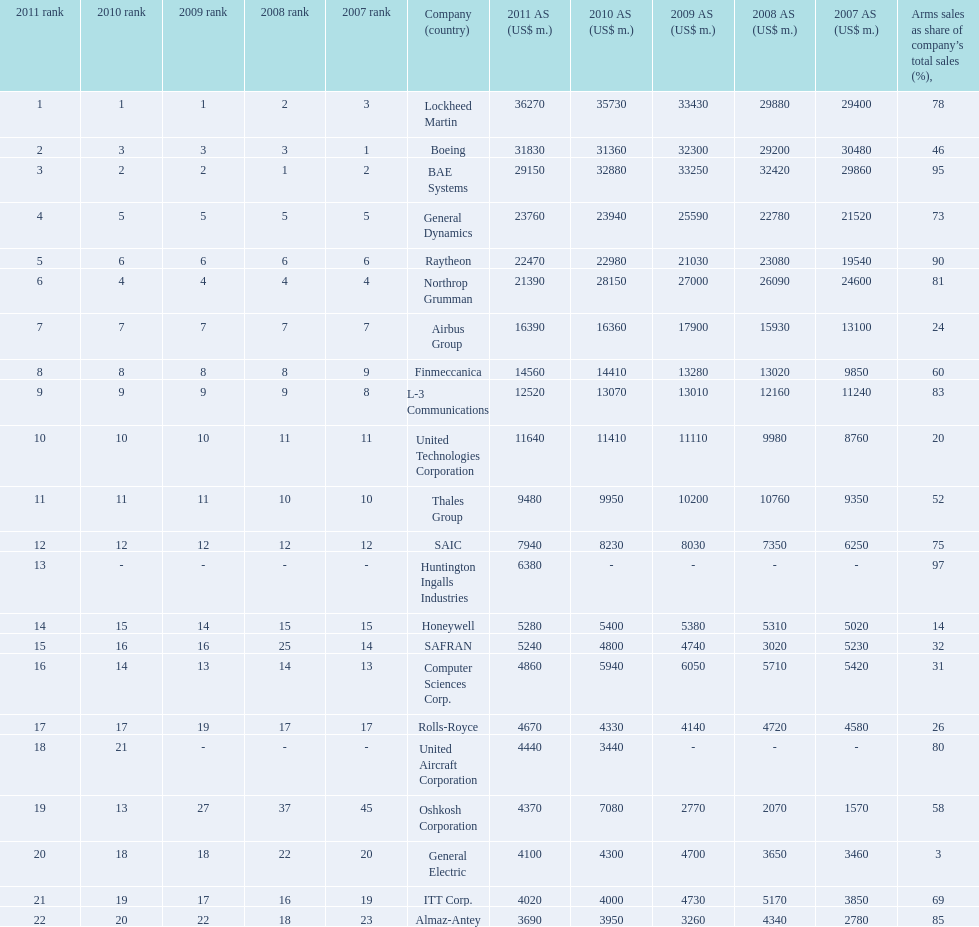Name all the companies whose arms sales as share of company's total sales is below 75%. Boeing, General Dynamics, Airbus Group, Finmeccanica, United Technologies Corporation, Thales Group, Honeywell, SAFRAN, Computer Sciences Corp., Rolls-Royce, Oshkosh Corporation, General Electric, ITT Corp. 